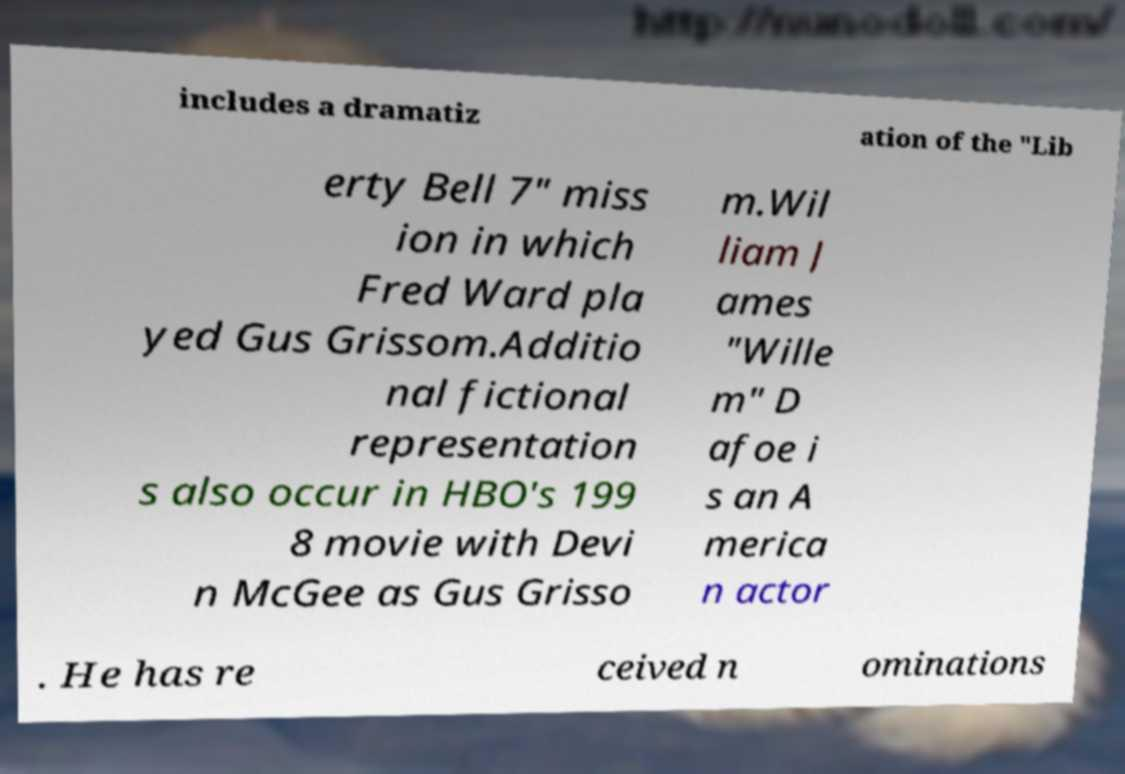Can you read and provide the text displayed in the image?This photo seems to have some interesting text. Can you extract and type it out for me? includes a dramatiz ation of the "Lib erty Bell 7" miss ion in which Fred Ward pla yed Gus Grissom.Additio nal fictional representation s also occur in HBO's 199 8 movie with Devi n McGee as Gus Grisso m.Wil liam J ames "Wille m" D afoe i s an A merica n actor . He has re ceived n ominations 